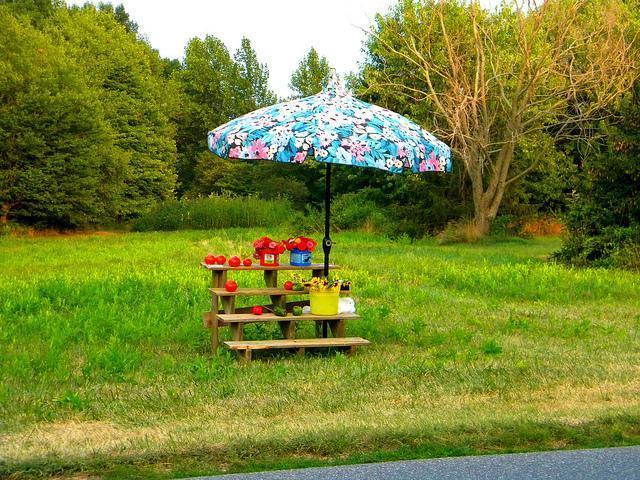How many umbrellas are visible?
Give a very brief answer. 1. 